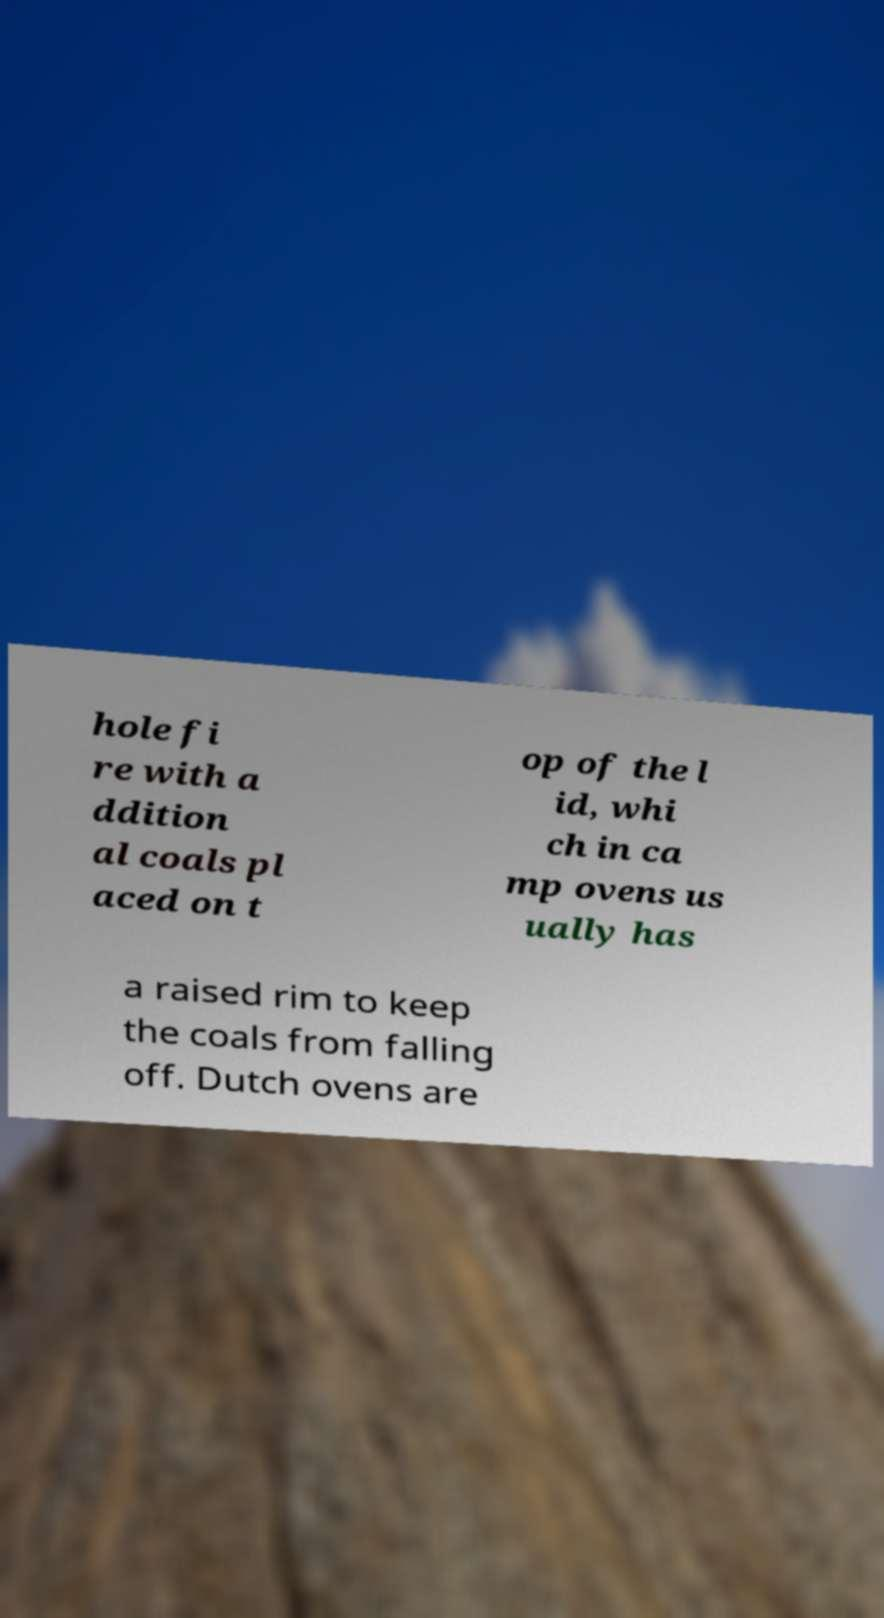There's text embedded in this image that I need extracted. Can you transcribe it verbatim? hole fi re with a ddition al coals pl aced on t op of the l id, whi ch in ca mp ovens us ually has a raised rim to keep the coals from falling off. Dutch ovens are 